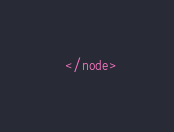<code> <loc_0><loc_0><loc_500><loc_500><_XML_>  </node></code> 